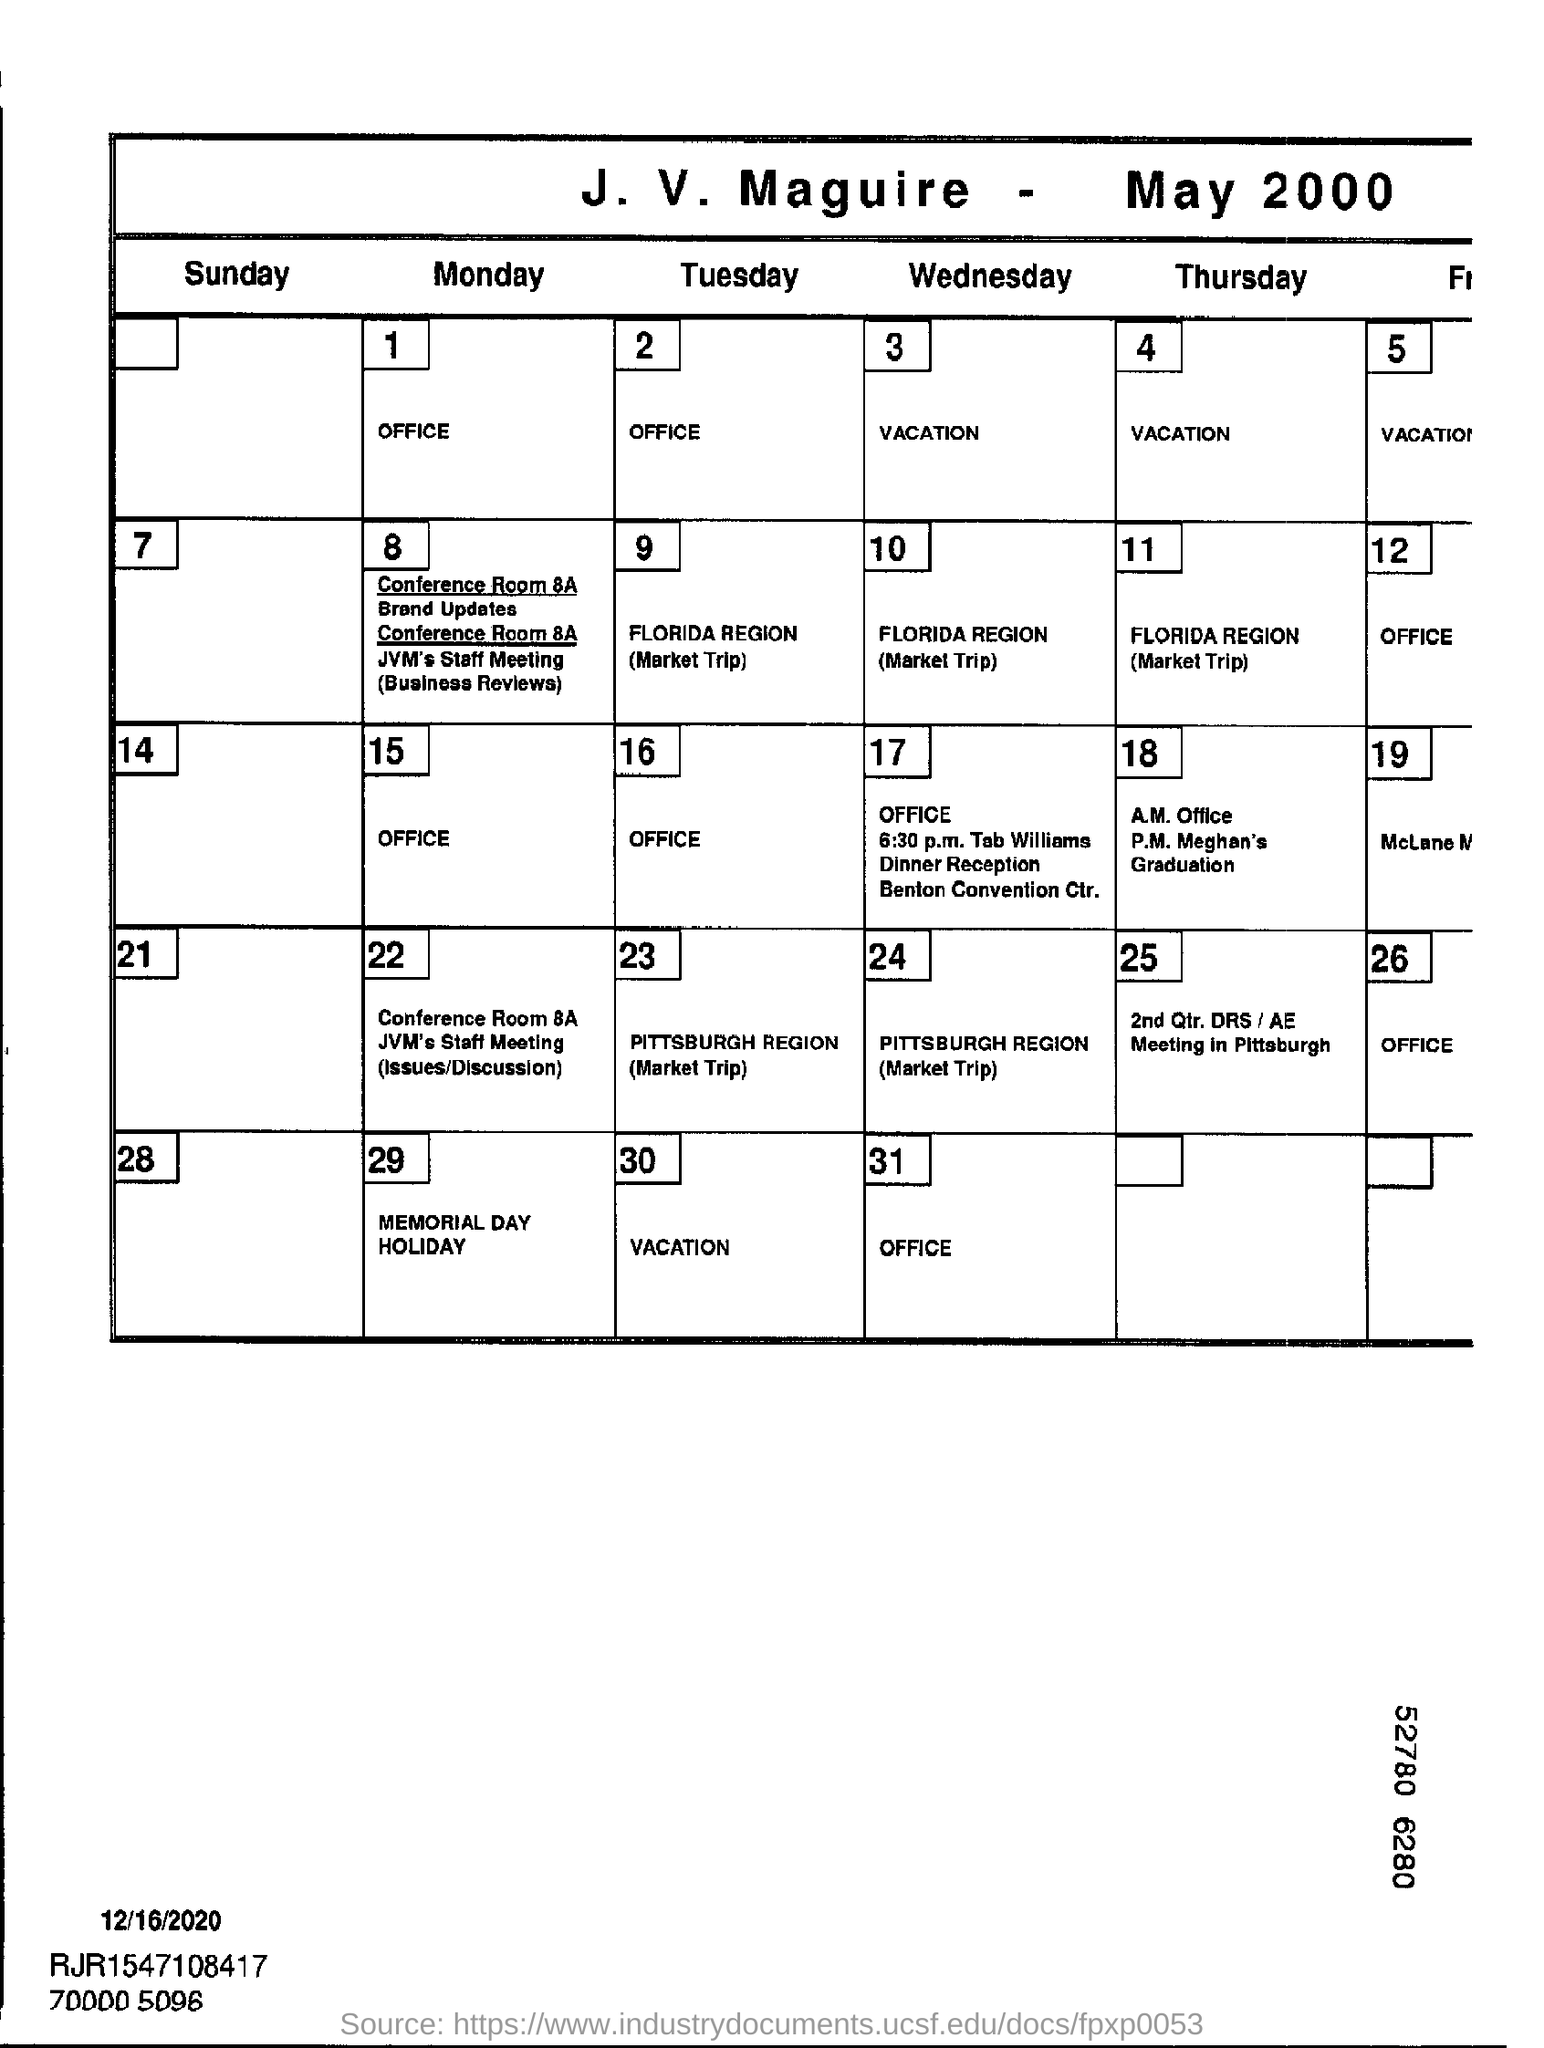What is the title of the document?
Provide a succinct answer. J. V. Maguire- May 2000. 